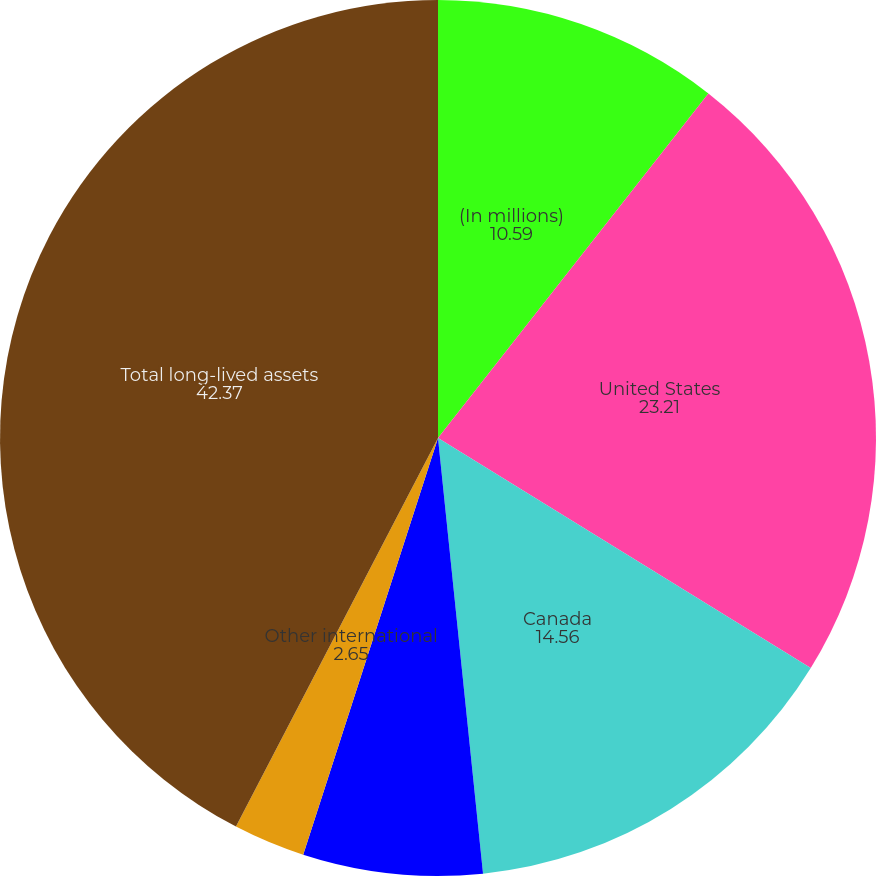Convert chart to OTSL. <chart><loc_0><loc_0><loc_500><loc_500><pie_chart><fcel>(In millions)<fcel>United States<fcel>Canada<fcel>Equatorial Guinea<fcel>Other international<fcel>Total long-lived assets<nl><fcel>10.59%<fcel>23.21%<fcel>14.56%<fcel>6.62%<fcel>2.65%<fcel>42.37%<nl></chart> 